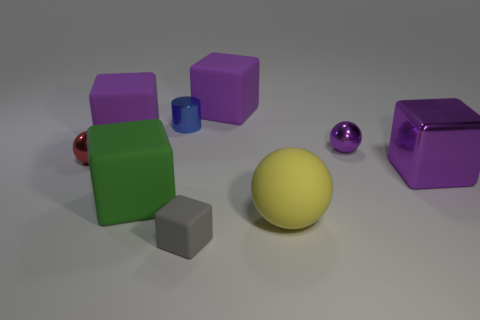There is a purple object that is on the left side of the gray matte thing; is its shape the same as the purple metal object that is behind the metal block?
Give a very brief answer. No. What is the shape of the tiny thing in front of the purple block on the right side of the rubber cube that is behind the tiny blue metal cylinder?
Your answer should be very brief. Cube. Is the number of tiny balls behind the big ball greater than the number of large metallic objects?
Your response must be concise. Yes. Is there a tiny red metal thing of the same shape as the small purple object?
Ensure brevity in your answer.  Yes. Is the material of the red thing the same as the tiny object that is in front of the shiny cube?
Your response must be concise. No. The big matte ball has what color?
Make the answer very short. Yellow. What number of large shiny blocks are right of the metal object that is in front of the tiny metal thing in front of the small purple metal ball?
Provide a short and direct response. 0. Are there any small metal things to the right of the big ball?
Your response must be concise. Yes. What number of tiny blue objects have the same material as the big yellow ball?
Make the answer very short. 0. How many objects are either big spheres or purple rubber things?
Your response must be concise. 3. 